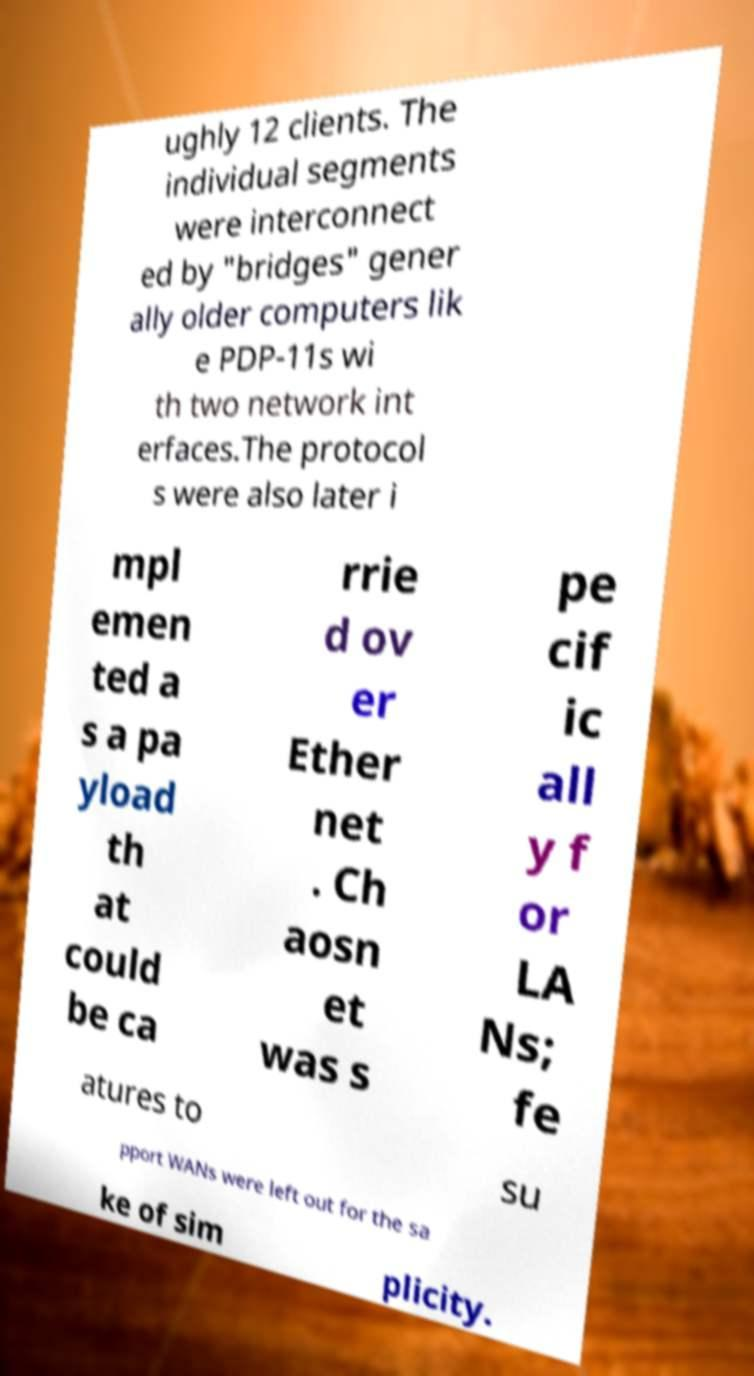I need the written content from this picture converted into text. Can you do that? ughly 12 clients. The individual segments were interconnect ed by "bridges" gener ally older computers lik e PDP-11s wi th two network int erfaces.The protocol s were also later i mpl emen ted a s a pa yload th at could be ca rrie d ov er Ether net . Ch aosn et was s pe cif ic all y f or LA Ns; fe atures to su pport WANs were left out for the sa ke of sim plicity. 